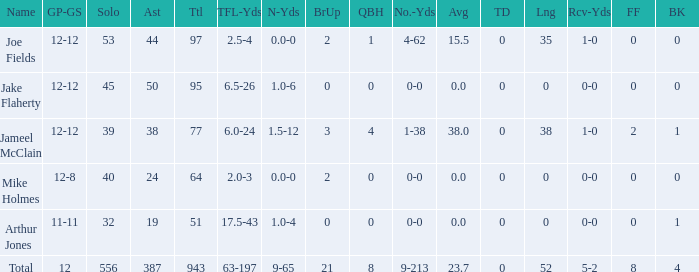How many players named jake flaherty? 1.0. 